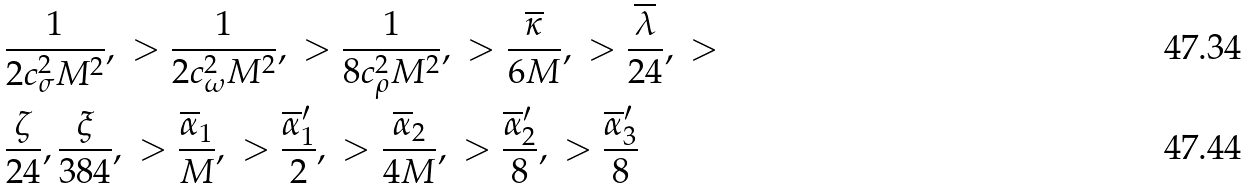Convert formula to latex. <formula><loc_0><loc_0><loc_500><loc_500>& \frac { 1 } { 2 c _ { \sigma } ^ { 2 } M ^ { 2 } } , \ > \frac { 1 } { 2 c _ { \omega } ^ { 2 } M ^ { 2 } } , \ > \frac { 1 } { 8 c _ { \rho } ^ { 2 } M ^ { 2 } } , \ > \frac { \overline { \kappa } } { 6 M } , \ > \frac { \overline { \lambda } } { 2 4 } , \ > \\ & \frac { \zeta } { 2 4 } , \frac { \xi } { 3 8 4 } , \ > \frac { \overline { \alpha } _ { 1 } } { M } , \ > \frac { \overline { \alpha } _ { 1 } ^ { \prime } } { 2 } , \ > \frac { \overline { \alpha } _ { 2 } } { 4 M } , \ > \frac { \overline { \alpha } _ { 2 } ^ { \prime } } { 8 } , \ > \frac { \overline { \alpha } _ { 3 } ^ { \prime } } { 8 }</formula> 